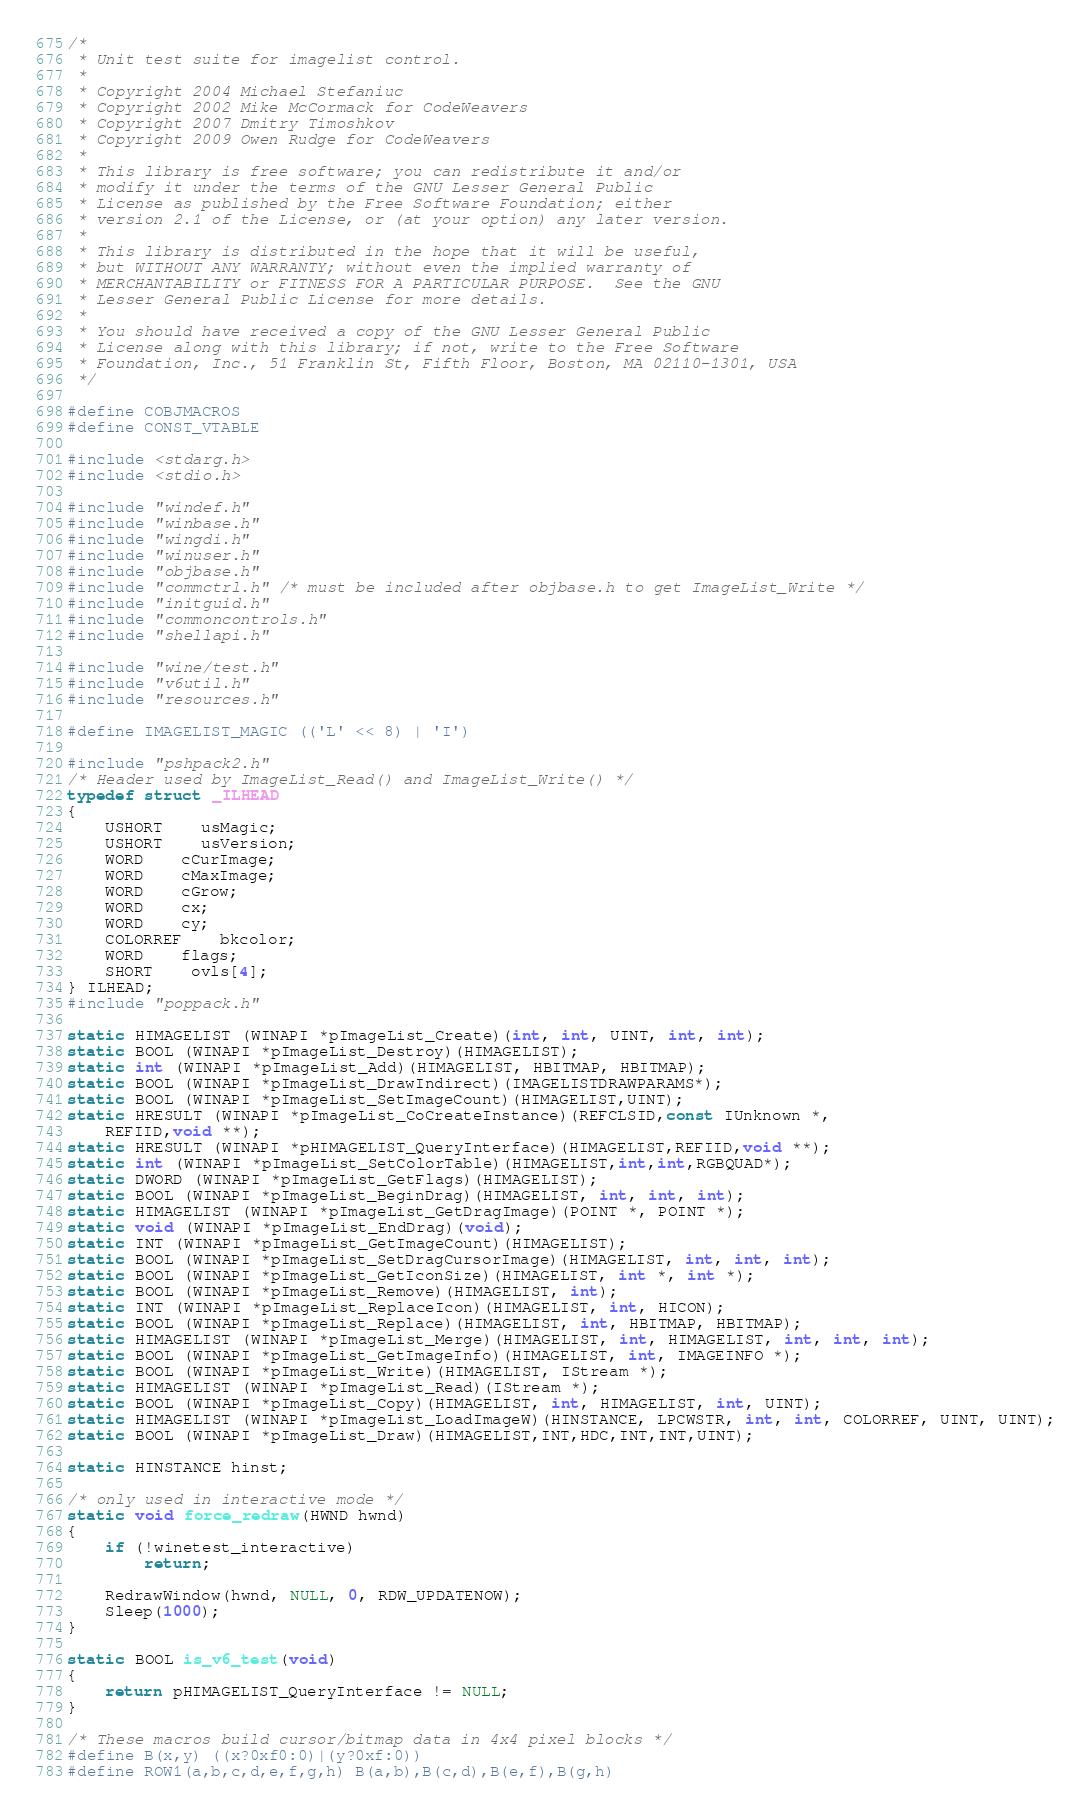<code> <loc_0><loc_0><loc_500><loc_500><_C_>/*
 * Unit test suite for imagelist control.
 *
 * Copyright 2004 Michael Stefaniuc
 * Copyright 2002 Mike McCormack for CodeWeavers
 * Copyright 2007 Dmitry Timoshkov
 * Copyright 2009 Owen Rudge for CodeWeavers
 *
 * This library is free software; you can redistribute it and/or
 * modify it under the terms of the GNU Lesser General Public
 * License as published by the Free Software Foundation; either
 * version 2.1 of the License, or (at your option) any later version.
 *
 * This library is distributed in the hope that it will be useful,
 * but WITHOUT ANY WARRANTY; without even the implied warranty of
 * MERCHANTABILITY or FITNESS FOR A PARTICULAR PURPOSE.  See the GNU
 * Lesser General Public License for more details.
 *
 * You should have received a copy of the GNU Lesser General Public
 * License along with this library; if not, write to the Free Software
 * Foundation, Inc., 51 Franklin St, Fifth Floor, Boston, MA 02110-1301, USA
 */

#define COBJMACROS
#define CONST_VTABLE

#include <stdarg.h>
#include <stdio.h>

#include "windef.h"
#include "winbase.h"
#include "wingdi.h"
#include "winuser.h"
#include "objbase.h"
#include "commctrl.h" /* must be included after objbase.h to get ImageList_Write */
#include "initguid.h"
#include "commoncontrols.h"
#include "shellapi.h"

#include "wine/test.h"
#include "v6util.h"
#include "resources.h"

#define IMAGELIST_MAGIC (('L' << 8) | 'I')

#include "pshpack2.h"
/* Header used by ImageList_Read() and ImageList_Write() */
typedef struct _ILHEAD
{
    USHORT	usMagic;
    USHORT	usVersion;
    WORD	cCurImage;
    WORD	cMaxImage;
    WORD	cGrow;
    WORD	cx;
    WORD	cy;
    COLORREF	bkcolor;
    WORD	flags;
    SHORT	ovls[4];
} ILHEAD;
#include "poppack.h"

static HIMAGELIST (WINAPI *pImageList_Create)(int, int, UINT, int, int);
static BOOL (WINAPI *pImageList_Destroy)(HIMAGELIST);
static int (WINAPI *pImageList_Add)(HIMAGELIST, HBITMAP, HBITMAP);
static BOOL (WINAPI *pImageList_DrawIndirect)(IMAGELISTDRAWPARAMS*);
static BOOL (WINAPI *pImageList_SetImageCount)(HIMAGELIST,UINT);
static HRESULT (WINAPI *pImageList_CoCreateInstance)(REFCLSID,const IUnknown *,
    REFIID,void **);
static HRESULT (WINAPI *pHIMAGELIST_QueryInterface)(HIMAGELIST,REFIID,void **);
static int (WINAPI *pImageList_SetColorTable)(HIMAGELIST,int,int,RGBQUAD*);
static DWORD (WINAPI *pImageList_GetFlags)(HIMAGELIST);
static BOOL (WINAPI *pImageList_BeginDrag)(HIMAGELIST, int, int, int);
static HIMAGELIST (WINAPI *pImageList_GetDragImage)(POINT *, POINT *);
static void (WINAPI *pImageList_EndDrag)(void);
static INT (WINAPI *pImageList_GetImageCount)(HIMAGELIST);
static BOOL (WINAPI *pImageList_SetDragCursorImage)(HIMAGELIST, int, int, int);
static BOOL (WINAPI *pImageList_GetIconSize)(HIMAGELIST, int *, int *);
static BOOL (WINAPI *pImageList_Remove)(HIMAGELIST, int);
static INT (WINAPI *pImageList_ReplaceIcon)(HIMAGELIST, int, HICON);
static BOOL (WINAPI *pImageList_Replace)(HIMAGELIST, int, HBITMAP, HBITMAP);
static HIMAGELIST (WINAPI *pImageList_Merge)(HIMAGELIST, int, HIMAGELIST, int, int, int);
static BOOL (WINAPI *pImageList_GetImageInfo)(HIMAGELIST, int, IMAGEINFO *);
static BOOL (WINAPI *pImageList_Write)(HIMAGELIST, IStream *);
static HIMAGELIST (WINAPI *pImageList_Read)(IStream *);
static BOOL (WINAPI *pImageList_Copy)(HIMAGELIST, int, HIMAGELIST, int, UINT);
static HIMAGELIST (WINAPI *pImageList_LoadImageW)(HINSTANCE, LPCWSTR, int, int, COLORREF, UINT, UINT);
static BOOL (WINAPI *pImageList_Draw)(HIMAGELIST,INT,HDC,INT,INT,UINT);

static HINSTANCE hinst;

/* only used in interactive mode */
static void force_redraw(HWND hwnd)
{
    if (!winetest_interactive)
        return;

    RedrawWindow(hwnd, NULL, 0, RDW_UPDATENOW);
    Sleep(1000);
}

static BOOL is_v6_test(void)
{
    return pHIMAGELIST_QueryInterface != NULL;
}

/* These macros build cursor/bitmap data in 4x4 pixel blocks */
#define B(x,y) ((x?0xf0:0)|(y?0xf:0))
#define ROW1(a,b,c,d,e,f,g,h) B(a,b),B(c,d),B(e,f),B(g,h)</code> 